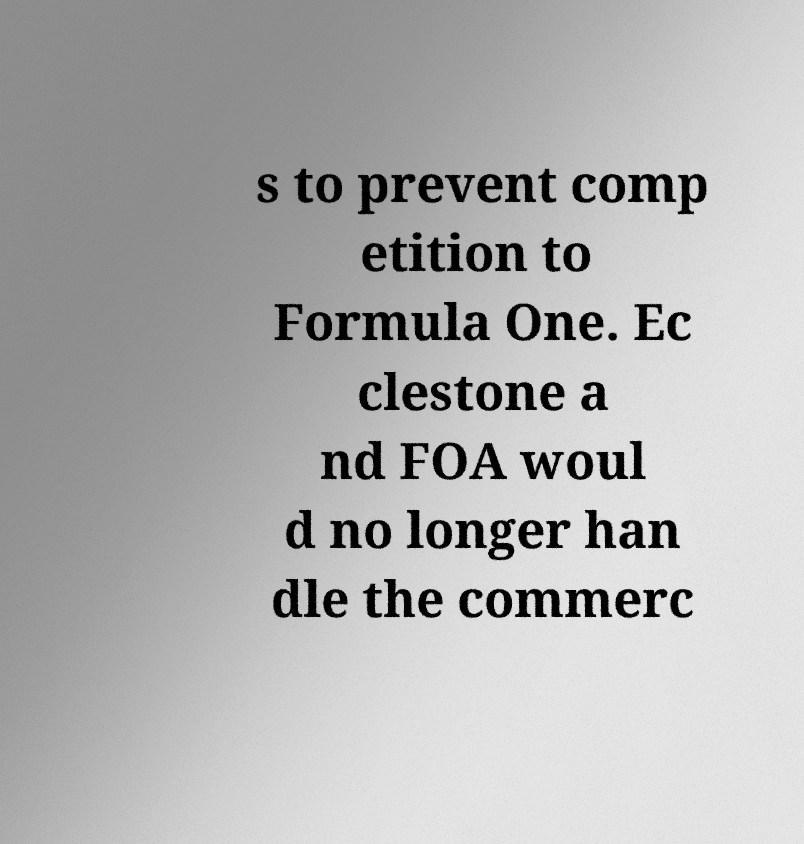Can you read and provide the text displayed in the image?This photo seems to have some interesting text. Can you extract and type it out for me? s to prevent comp etition to Formula One. Ec clestone a nd FOA woul d no longer han dle the commerc 